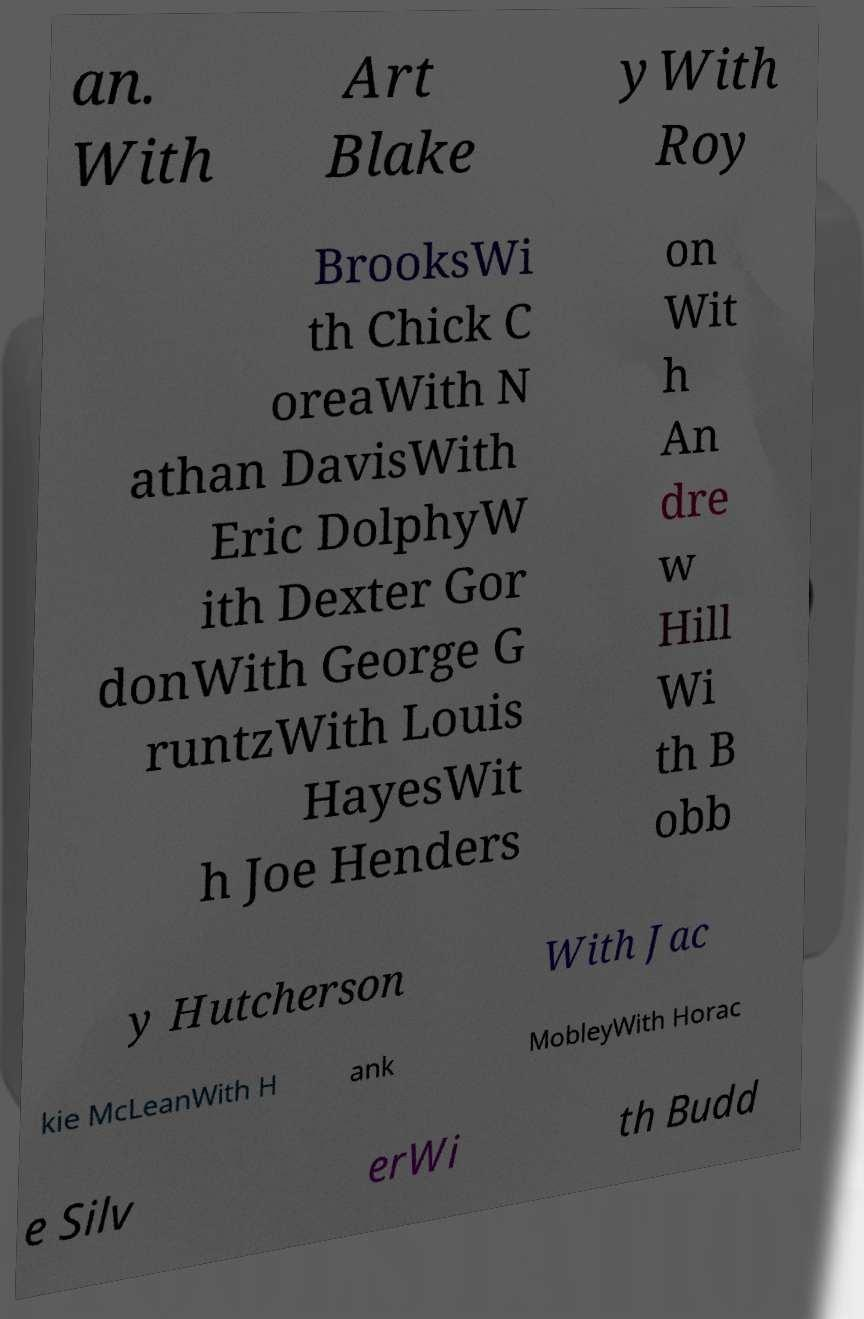I need the written content from this picture converted into text. Can you do that? an. With Art Blake yWith Roy BrooksWi th Chick C oreaWith N athan DavisWith Eric DolphyW ith Dexter Gor donWith George G runtzWith Louis HayesWit h Joe Henders on Wit h An dre w Hill Wi th B obb y Hutcherson With Jac kie McLeanWith H ank MobleyWith Horac e Silv erWi th Budd 